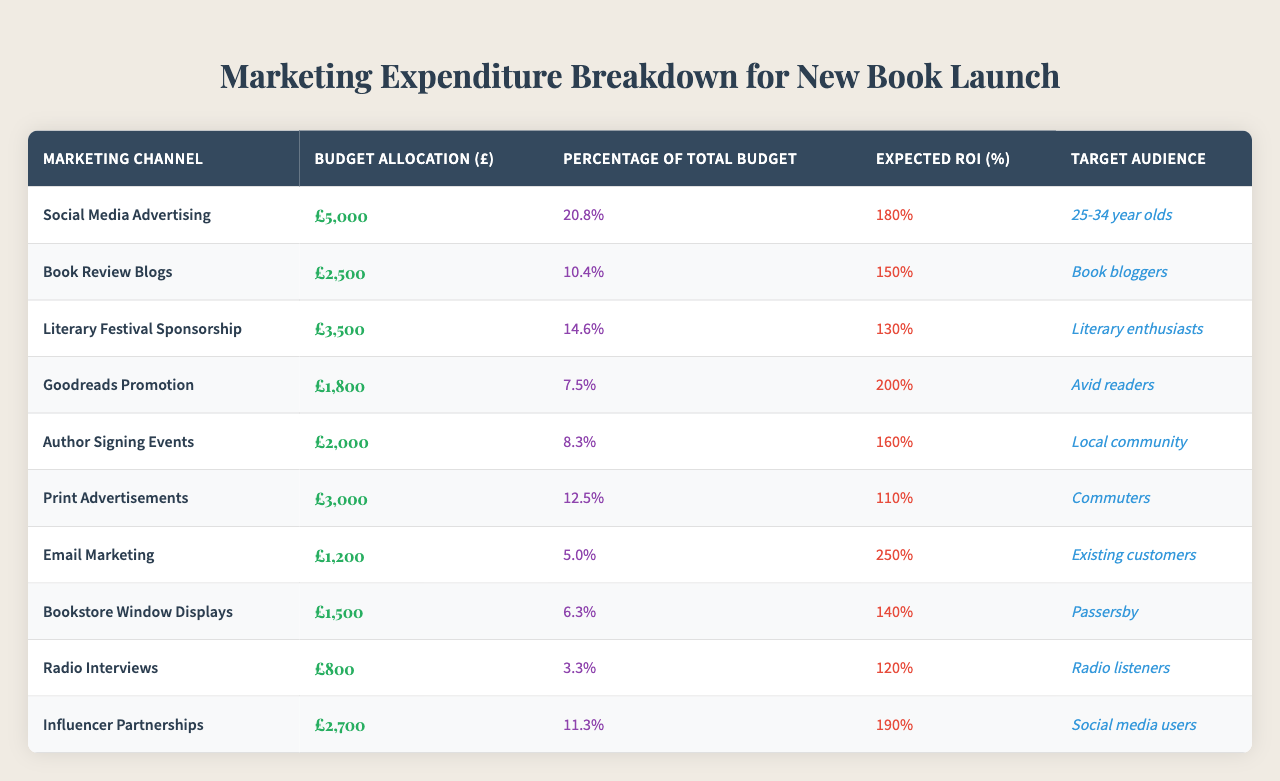What is the budget allocated for Social Media Advertising? The table shows that the budget allocated for Social Media Advertising is £5000.
Answer: £5000 Which marketing channel has the lowest budget allocation? By reviewing the table, it can be noted that Email Marketing has the lowest budget allocation of £1200.
Answer: Email Marketing What percentage of the total budget is allocated to Book Review Blogs? The table indicates that Book Review Blogs have a budget allocation that represents 10.4% of the total budget.
Answer: 10.4% What is the expected ROI for Author Signing Events? The table lists the expected ROI for Author Signing Events as 160%.
Answer: 160% How much more is allocated to Social Media Advertising compared to Goodreads Promotion? The budget allocated to Social Media Advertising is £5000, while Goodreads Promotion is £1800. The difference is £5000 - £1800 = £3200.
Answer: £3200 What is the average expected ROI across all marketing channels? To find the average expected ROI, sum all the expected ROI values: (180 + 150 + 130 + 200 + 160 + 110 + 250 + 140 + 120 + 190) = 1880, then divide by the number of channels (10): 1880 / 10 = 188.
Answer: 188 Are Print Advertisements allocated more than 10% of the total budget? The table shows Print Advertisements represent 12.5% of the total budget, which is greater than 10%.
Answer: Yes Which marketing channel has the highest expected ROI? By examining the table, it is clear that Email Marketing has the highest expected ROI of 250%.
Answer: Email Marketing How much total budget is allocated to marketing channels targeting readers aged 25-34 and local communities? The allocations for Social Media Advertising (targeting 25-34 year olds) is £5000 and for Author Signing Events (targeting local community) is £2000. Adding these gives £5000 + £2000 = £7000.
Answer: £7000 What is the percentage of total budget allocated to Influencer Partnerships compared to Bookstore Window Displays? Influencer Partnerships are allocated 11.3% and Bookstore Window Displays are allocated 6.3%. The difference is 11.3% - 6.3% = 5%.
Answer: 5% 